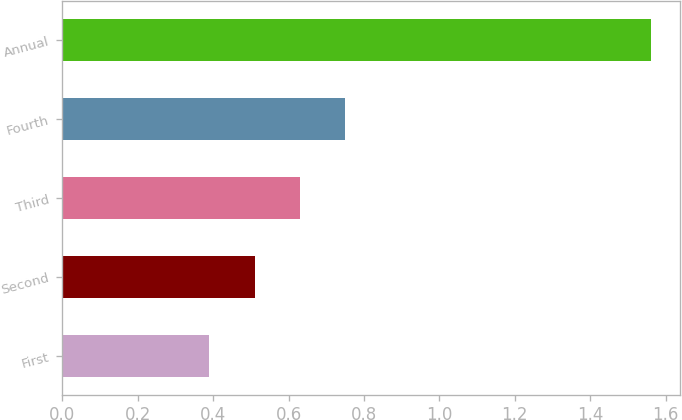Convert chart to OTSL. <chart><loc_0><loc_0><loc_500><loc_500><bar_chart><fcel>First<fcel>Second<fcel>Third<fcel>Fourth<fcel>Annual<nl><fcel>0.39<fcel>0.51<fcel>0.63<fcel>0.75<fcel>1.56<nl></chart> 